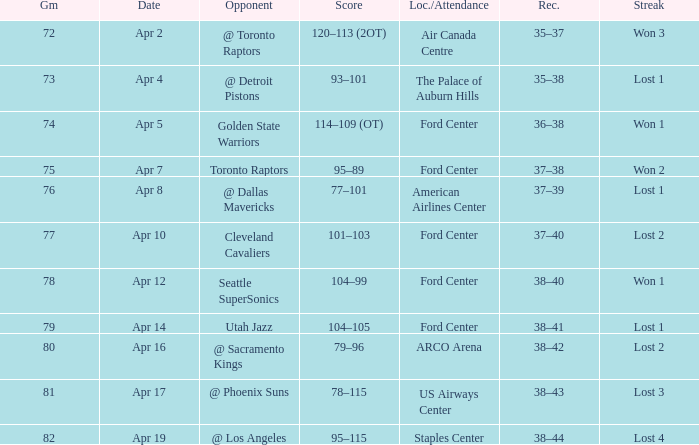Who was the opponent for game 75? Toronto Raptors. 